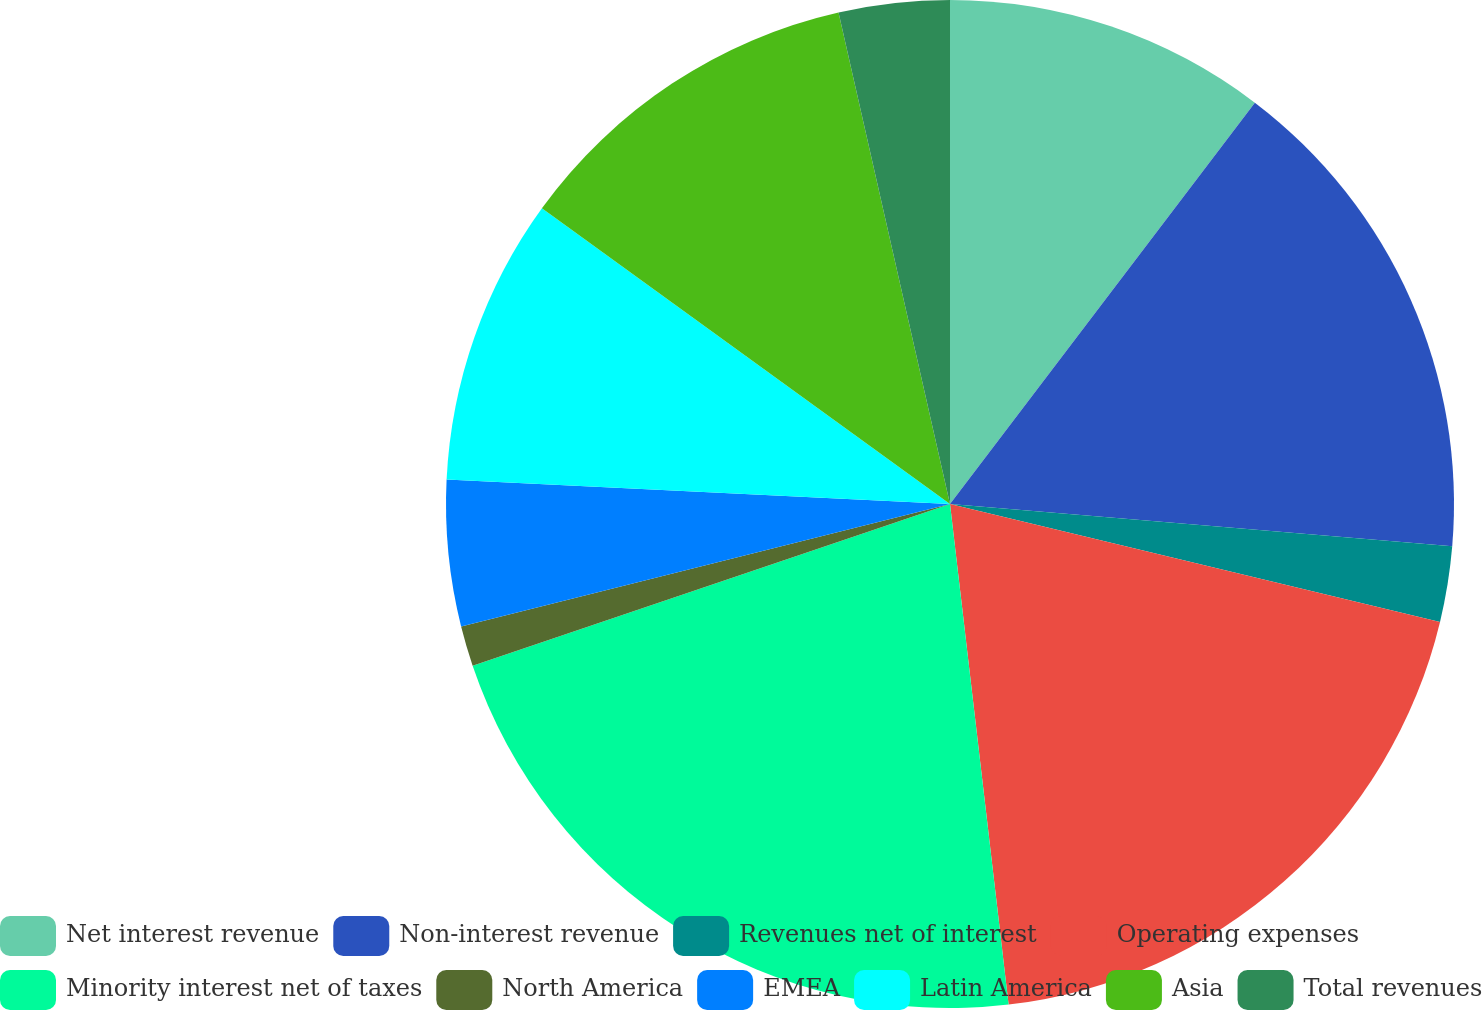Convert chart. <chart><loc_0><loc_0><loc_500><loc_500><pie_chart><fcel>Net interest revenue<fcel>Non-interest revenue<fcel>Revenues net of interest<fcel>Operating expenses<fcel>Minority interest net of taxes<fcel>North America<fcel>EMEA<fcel>Latin America<fcel>Asia<fcel>Total revenues<nl><fcel>10.34%<fcel>16.0%<fcel>2.42%<fcel>19.39%<fcel>21.66%<fcel>1.29%<fcel>4.68%<fcel>9.21%<fcel>11.47%<fcel>3.55%<nl></chart> 